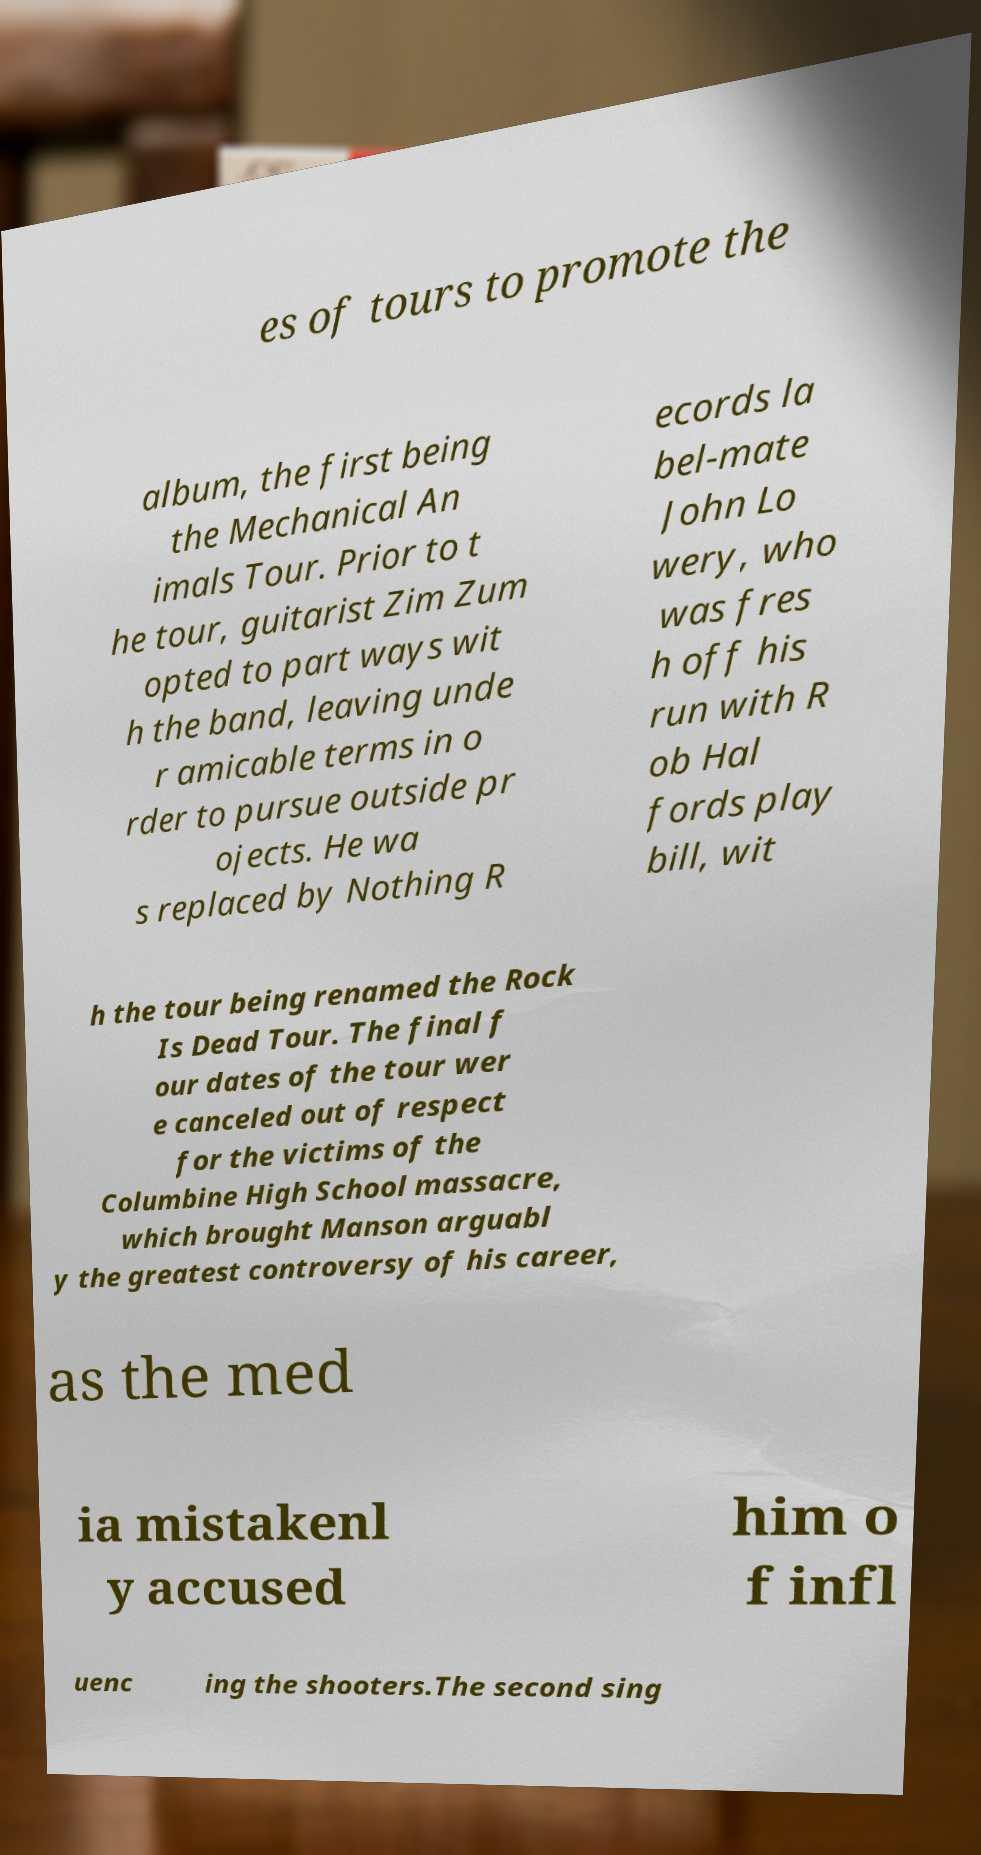What messages or text are displayed in this image? I need them in a readable, typed format. es of tours to promote the album, the first being the Mechanical An imals Tour. Prior to t he tour, guitarist Zim Zum opted to part ways wit h the band, leaving unde r amicable terms in o rder to pursue outside pr ojects. He wa s replaced by Nothing R ecords la bel-mate John Lo wery, who was fres h off his run with R ob Hal fords play bill, wit h the tour being renamed the Rock Is Dead Tour. The final f our dates of the tour wer e canceled out of respect for the victims of the Columbine High School massacre, which brought Manson arguabl y the greatest controversy of his career, as the med ia mistakenl y accused him o f infl uenc ing the shooters.The second sing 